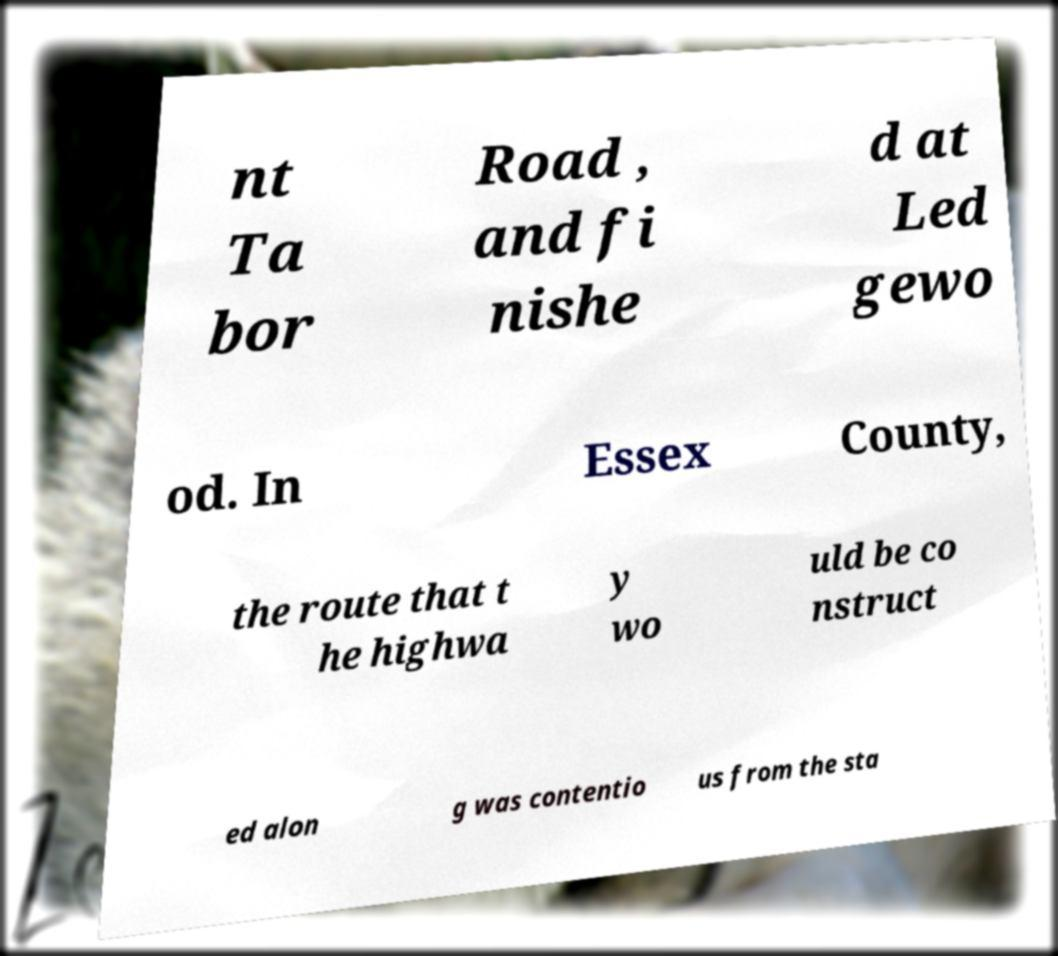Can you read and provide the text displayed in the image?This photo seems to have some interesting text. Can you extract and type it out for me? nt Ta bor Road , and fi nishe d at Led gewo od. In Essex County, the route that t he highwa y wo uld be co nstruct ed alon g was contentio us from the sta 